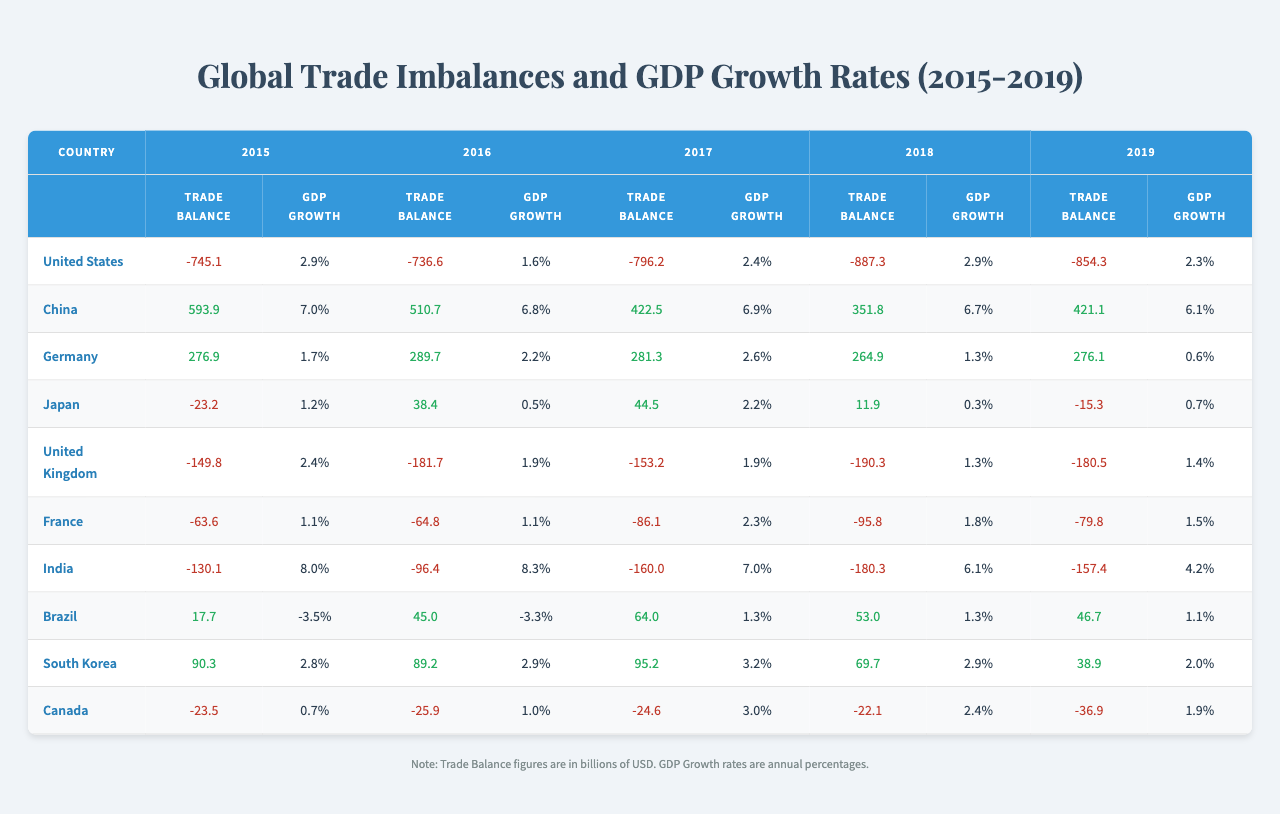What was the trade balance of the United States in 2019? The table shows that the trade balance of the United States in 2019 is -854.3 billion USD.
Answer: -854.3 billion USD Which country had the highest GDP growth rate in 2015? By examining the GDP growth rates for 2015, India had the highest rate at 8.0%.
Answer: India What is the average trade balance for Germany over the years 2015 to 2019? To find the average, add the trade balances: 276.9 + 289.7 + 281.3 + 264.9 + 276.1 = 1389.9. Then divide by 5, resulting in an average of 277.98 billion USD.
Answer: 277.98 billion USD Did Brazil experience a positive trade balance during any of the years from 2015 to 2019? Looking at the trade balance for Brazil, it had positive values in 2015, 2016, 2017, and 2018, so it did experience positive trade balances during these years.
Answer: Yes What was the trend in GDP growth for China from 2015 to 2019? From the table, China's GDP growth rates decreased from 7.0% in 2015 to 6.1% in 2019, indicating a downward trend.
Answer: Downward trend How much larger was China's trade balance compared to the United States' trade balance in 2017? China's trade balance in 2017 was 422.5 billion USD, and the United States' was -796.2 billion USD. The difference is 422.5 - (-796.2) = 1218.7 billion USD.
Answer: 1218.7 billion USD What was the lowest GDP growth rate recorded in the table for any country in 2019? The table indicates that Germany had the lowest GDP growth rate in 2019 at 0.6%.
Answer: 0.6% Which country experienced the most significant year-to-year decrease in GDP growth from 2016 to 2017? By comparing the GDP growth rates, India decreased from 8.3% in 2016 to 7.0% in 2017, making a difference of 1.3%, which is the largest decline.
Answer: India What was the average GDP growth rate of France from 2015 to 2019? The average can be calculated as follows: (1.1 + 1.1 + 2.3 + 1.8 + 1.5) / 5 = 1.42%.
Answer: 1.42% Did South Korea's trade balance ever become negative from 2015 to 2019? Referring to the table, South Korea maintained a positive trade balance in all years from 2015 to 2019.
Answer: No What is the relationship between India’s trade balance and GDP growth from 2015 to 2019? India’s trade balances were consistently negative while GDP growth was high initially at 8.0% in 2015 and decreased to 4.2% in 2019, suggesting that trade imbalances may not directly correlate with GDP growth rates for India.
Answer: Negative trade balance, declining GDP growth 